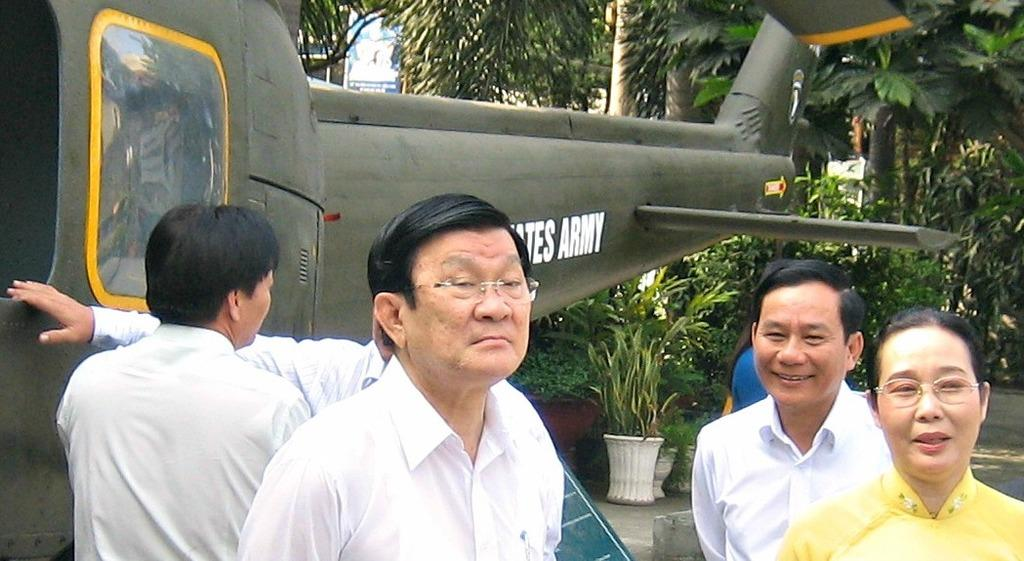Provide a one-sentence caption for the provided image. Group of people standing in front of a plane that says "Army" on it. 